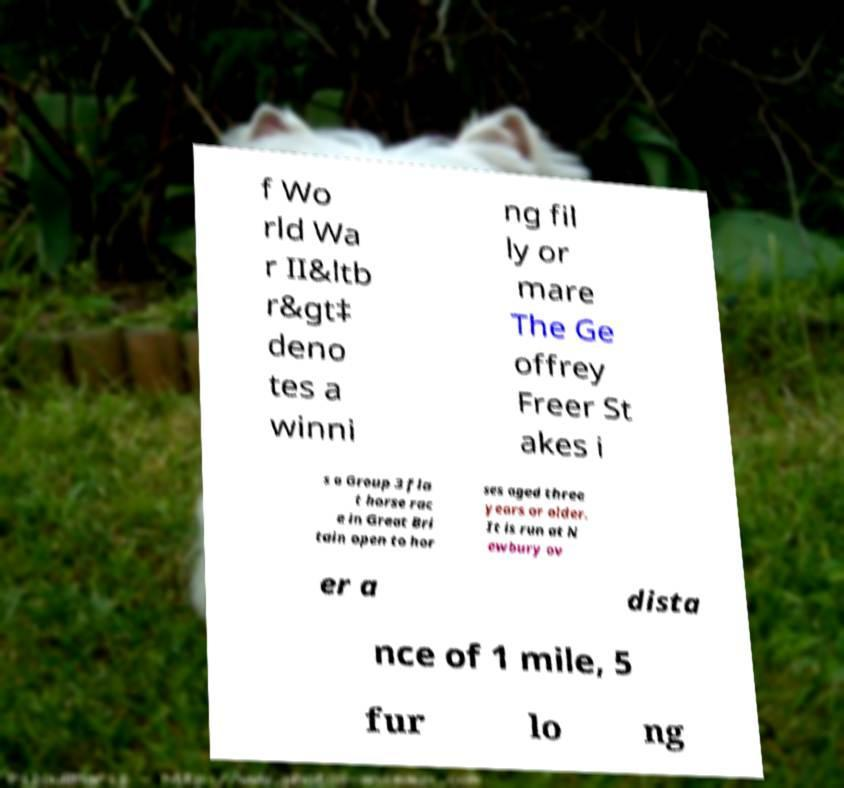There's text embedded in this image that I need extracted. Can you transcribe it verbatim? f Wo rld Wa r II&ltb r&gt‡ deno tes a winni ng fil ly or mare The Ge offrey Freer St akes i s a Group 3 fla t horse rac e in Great Bri tain open to hor ses aged three years or older. It is run at N ewbury ov er a dista nce of 1 mile, 5 fur lo ng 